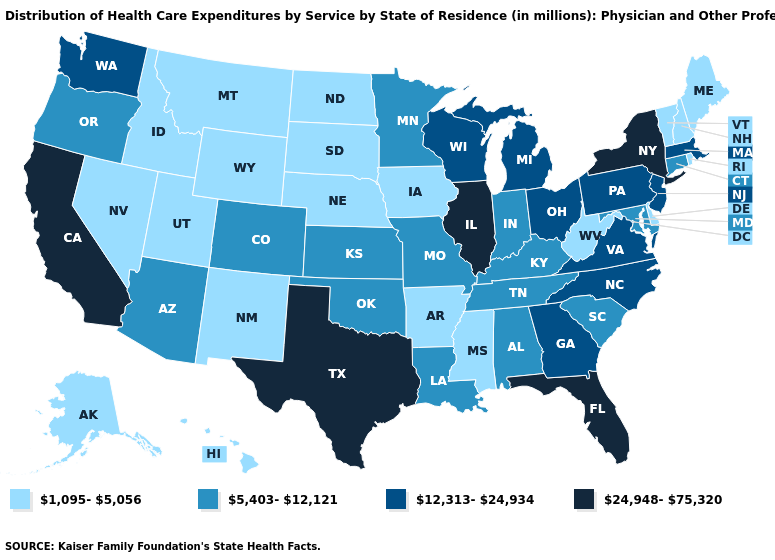What is the value of Ohio?
Concise answer only. 12,313-24,934. Name the states that have a value in the range 24,948-75,320?
Write a very short answer. California, Florida, Illinois, New York, Texas. Does Connecticut have the lowest value in the Northeast?
Be succinct. No. Is the legend a continuous bar?
Quick response, please. No. Among the states that border Montana , which have the lowest value?
Be succinct. Idaho, North Dakota, South Dakota, Wyoming. Does Illinois have the highest value in the USA?
Quick response, please. Yes. Name the states that have a value in the range 12,313-24,934?
Short answer required. Georgia, Massachusetts, Michigan, New Jersey, North Carolina, Ohio, Pennsylvania, Virginia, Washington, Wisconsin. Name the states that have a value in the range 12,313-24,934?
Answer briefly. Georgia, Massachusetts, Michigan, New Jersey, North Carolina, Ohio, Pennsylvania, Virginia, Washington, Wisconsin. What is the value of Kentucky?
Be succinct. 5,403-12,121. What is the value of Alaska?
Quick response, please. 1,095-5,056. Name the states that have a value in the range 24,948-75,320?
Write a very short answer. California, Florida, Illinois, New York, Texas. Which states have the lowest value in the Northeast?
Concise answer only. Maine, New Hampshire, Rhode Island, Vermont. What is the highest value in states that border New Hampshire?
Quick response, please. 12,313-24,934. Which states hav the highest value in the West?
Write a very short answer. California. 